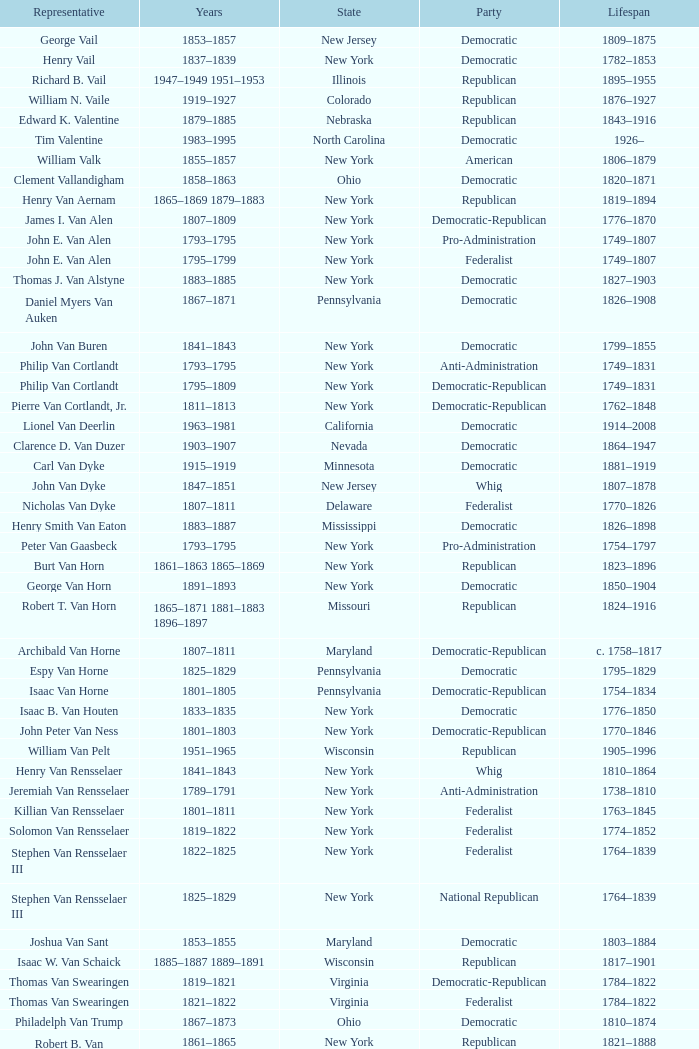What is the lifespan of Joseph Vance, a democratic-republican from Ohio? 1786–1852. 